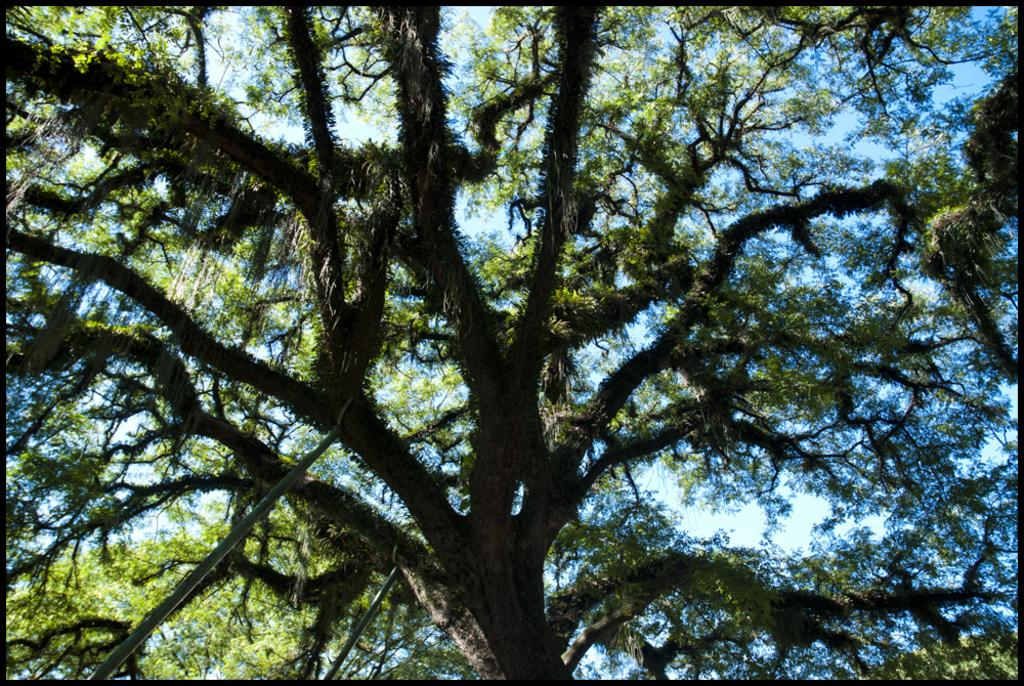What type of vegetation can be seen in the image? There are trees visible in the image. What can be seen in the sky in the image? Clouds are present in the sky in the image. What type of car is parked under the trees in the image? There is no car present in the image; it only features trees and clouds. What message is being conveyed by the board in the image? There is no board present in the image, so no message can be conveyed. 